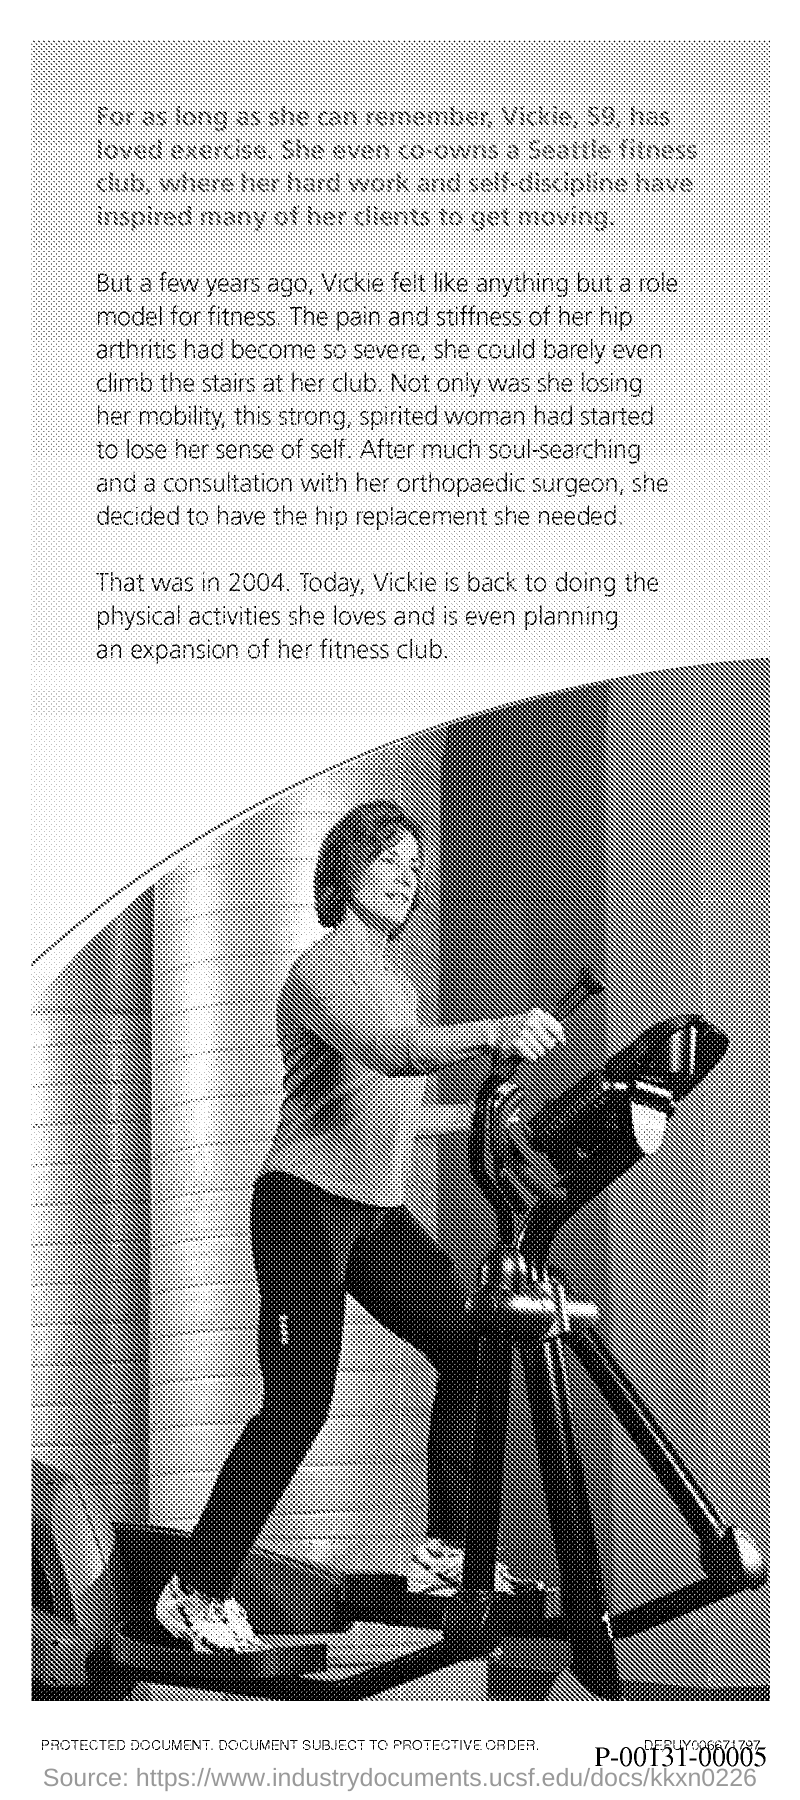List a handful of essential elements in this visual. Vickie had her hip surgery in the year 2004. Vicky consulted with an orthopaedic surgeon. The age of Vicky is 59. 